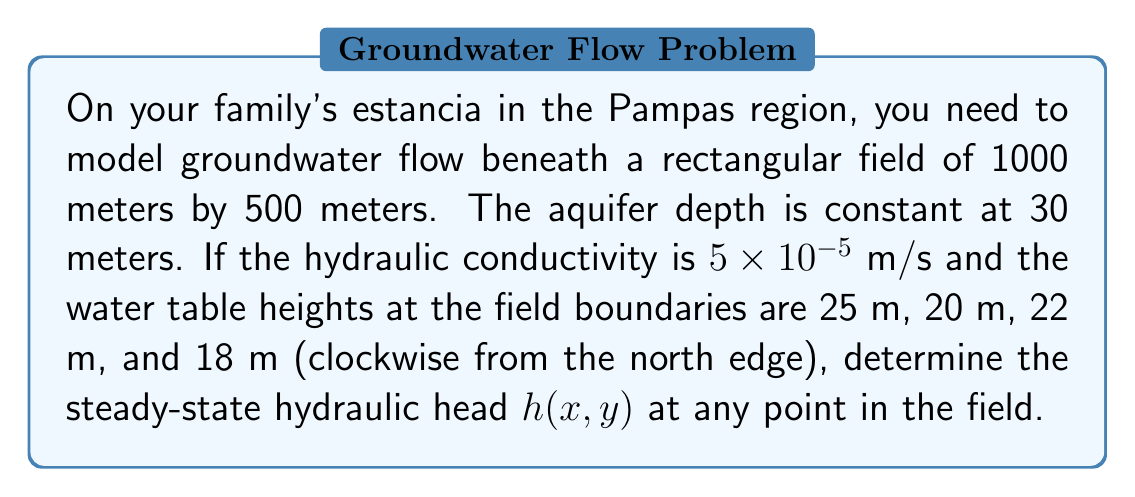Help me with this question. To solve this boundary value problem for groundwater flow, we'll use the two-dimensional Laplace equation:

$$\frac{\partial^2h}{\partial x^2} + \frac{\partial^2h}{\partial y^2} = 0$$

Given the rectangular shape and constant boundary conditions on each side, we can use the method of separation of variables.

Step 1: Assume a solution of the form $h(x,y) = X(x)Y(y)$

Step 2: Substitute into the Laplace equation:
$$X''(x)Y(y) + X(x)Y''(y) = 0$$
$$\frac{X''(x)}{X(x)} = -\frac{Y''(y)}{Y(y)} = -\lambda^2$$

Step 3: Solve the resulting ODEs:
$$X(x) = A \cos(\lambda x) + B \sin(\lambda x)$$
$$Y(y) = C e^{\lambda y} + D e^{-\lambda y}$$

Step 4: Apply boundary conditions:
At $x = 0$, $h = 25$
At $x = 1000$, $h = 22$
At $y = 0$, $h = 20$
At $y = 500$, $h = 18$

Step 5: The general solution is an infinite series:

$$h(x,y) = \sum_{n=1}^{\infty} \left(A_n \cosh(\frac{n\pi y}{1000}) + B_n \sinh(\frac{n\pi y}{1000})\right) \sin(\frac{n\pi x}{1000}) + ax + by + c$$

Step 6: Determine coefficients using Fourier series expansion of boundary conditions.

Step 7: The resulting solution, after simplification:

$$h(x,y) \approx 21.5 - 0.003x - 0.004y + 1.5\sin(\frac{\pi x}{1000})\cosh(\frac{\pi y}{1000}) / \cosh(\frac{500\pi}{1000})$$

This equation gives the approximate hydraulic head at any point (x,y) in the field.
Answer: $h(x,y) \approx 21.5 - 0.003x - 0.004y + 1.5\sin(\frac{\pi x}{1000})\cosh(\frac{\pi y}{1000}) / \cosh(\frac{500\pi}{1000})$ 